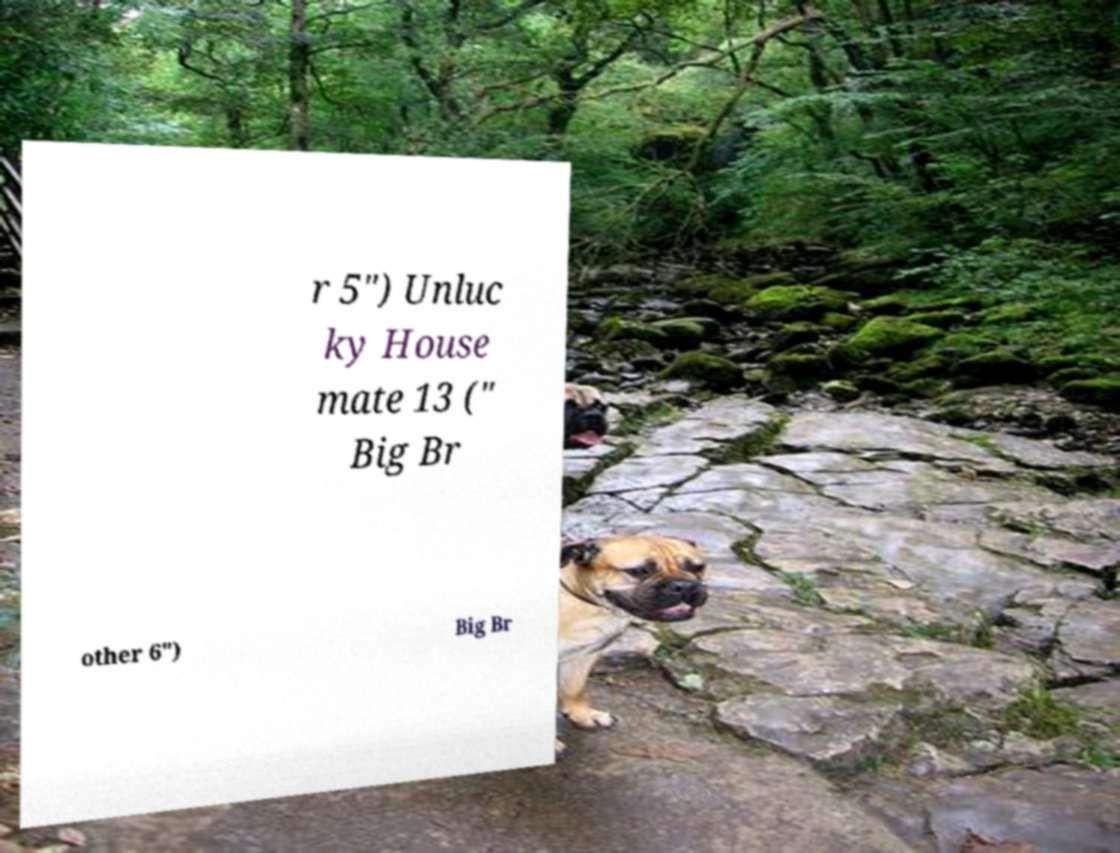Can you read and provide the text displayed in the image?This photo seems to have some interesting text. Can you extract and type it out for me? r 5") Unluc ky House mate 13 (" Big Br other 6") Big Br 